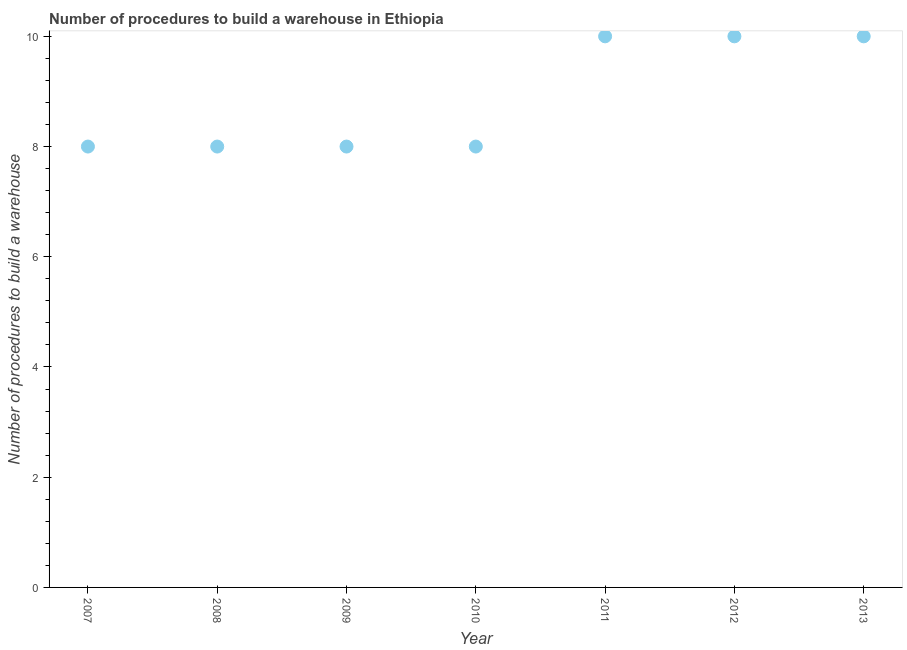What is the number of procedures to build a warehouse in 2009?
Keep it short and to the point. 8. Across all years, what is the maximum number of procedures to build a warehouse?
Make the answer very short. 10. Across all years, what is the minimum number of procedures to build a warehouse?
Your answer should be compact. 8. In which year was the number of procedures to build a warehouse maximum?
Offer a very short reply. 2011. What is the sum of the number of procedures to build a warehouse?
Keep it short and to the point. 62. What is the difference between the number of procedures to build a warehouse in 2008 and 2012?
Your answer should be very brief. -2. What is the average number of procedures to build a warehouse per year?
Provide a short and direct response. 8.86. What is the median number of procedures to build a warehouse?
Make the answer very short. 8. Is the sum of the number of procedures to build a warehouse in 2011 and 2013 greater than the maximum number of procedures to build a warehouse across all years?
Your answer should be very brief. Yes. What is the difference between the highest and the lowest number of procedures to build a warehouse?
Make the answer very short. 2. How many years are there in the graph?
Give a very brief answer. 7. Are the values on the major ticks of Y-axis written in scientific E-notation?
Provide a succinct answer. No. Does the graph contain any zero values?
Give a very brief answer. No. Does the graph contain grids?
Offer a very short reply. No. What is the title of the graph?
Offer a very short reply. Number of procedures to build a warehouse in Ethiopia. What is the label or title of the Y-axis?
Give a very brief answer. Number of procedures to build a warehouse. What is the Number of procedures to build a warehouse in 2007?
Keep it short and to the point. 8. What is the Number of procedures to build a warehouse in 2008?
Your answer should be very brief. 8. What is the Number of procedures to build a warehouse in 2009?
Your response must be concise. 8. What is the Number of procedures to build a warehouse in 2010?
Provide a succinct answer. 8. What is the difference between the Number of procedures to build a warehouse in 2007 and 2009?
Offer a terse response. 0. What is the difference between the Number of procedures to build a warehouse in 2007 and 2011?
Provide a succinct answer. -2. What is the difference between the Number of procedures to build a warehouse in 2007 and 2012?
Give a very brief answer. -2. What is the difference between the Number of procedures to build a warehouse in 2008 and 2012?
Provide a short and direct response. -2. What is the difference between the Number of procedures to build a warehouse in 2009 and 2010?
Your answer should be compact. 0. What is the difference between the Number of procedures to build a warehouse in 2009 and 2011?
Your answer should be compact. -2. What is the difference between the Number of procedures to build a warehouse in 2009 and 2012?
Your answer should be compact. -2. What is the difference between the Number of procedures to build a warehouse in 2009 and 2013?
Give a very brief answer. -2. What is the difference between the Number of procedures to build a warehouse in 2012 and 2013?
Your response must be concise. 0. What is the ratio of the Number of procedures to build a warehouse in 2007 to that in 2010?
Your answer should be compact. 1. What is the ratio of the Number of procedures to build a warehouse in 2008 to that in 2009?
Give a very brief answer. 1. What is the ratio of the Number of procedures to build a warehouse in 2008 to that in 2010?
Your answer should be compact. 1. What is the ratio of the Number of procedures to build a warehouse in 2008 to that in 2011?
Offer a very short reply. 0.8. What is the ratio of the Number of procedures to build a warehouse in 2008 to that in 2013?
Offer a terse response. 0.8. What is the ratio of the Number of procedures to build a warehouse in 2010 to that in 2011?
Make the answer very short. 0.8. What is the ratio of the Number of procedures to build a warehouse in 2010 to that in 2013?
Ensure brevity in your answer.  0.8. What is the ratio of the Number of procedures to build a warehouse in 2011 to that in 2012?
Make the answer very short. 1. 